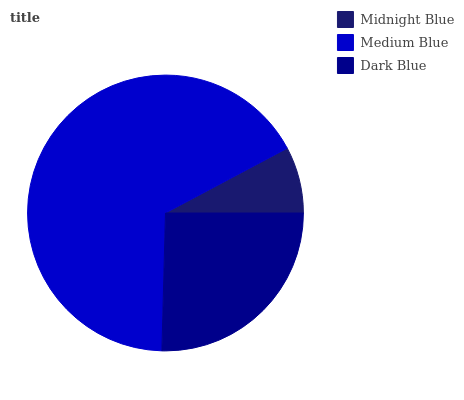Is Midnight Blue the minimum?
Answer yes or no. Yes. Is Medium Blue the maximum?
Answer yes or no. Yes. Is Dark Blue the minimum?
Answer yes or no. No. Is Dark Blue the maximum?
Answer yes or no. No. Is Medium Blue greater than Dark Blue?
Answer yes or no. Yes. Is Dark Blue less than Medium Blue?
Answer yes or no. Yes. Is Dark Blue greater than Medium Blue?
Answer yes or no. No. Is Medium Blue less than Dark Blue?
Answer yes or no. No. Is Dark Blue the high median?
Answer yes or no. Yes. Is Dark Blue the low median?
Answer yes or no. Yes. Is Midnight Blue the high median?
Answer yes or no. No. Is Medium Blue the low median?
Answer yes or no. No. 